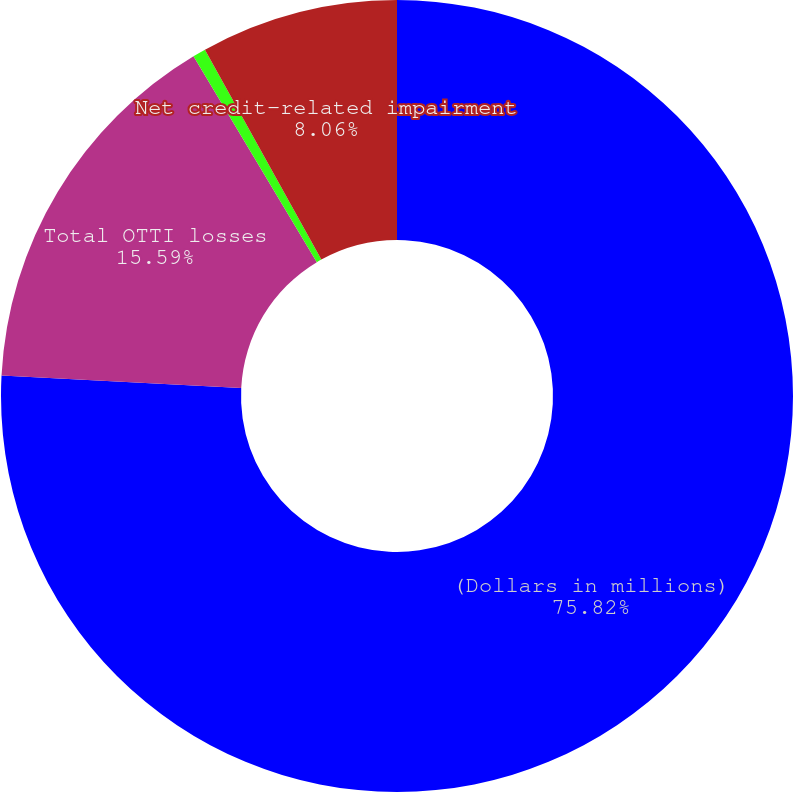Convert chart to OTSL. <chart><loc_0><loc_0><loc_500><loc_500><pie_chart><fcel>(Dollars in millions)<fcel>Total OTTI losses<fcel>Less non-credit portion of<fcel>Net credit-related impairment<nl><fcel>75.83%<fcel>15.59%<fcel>0.53%<fcel>8.06%<nl></chart> 